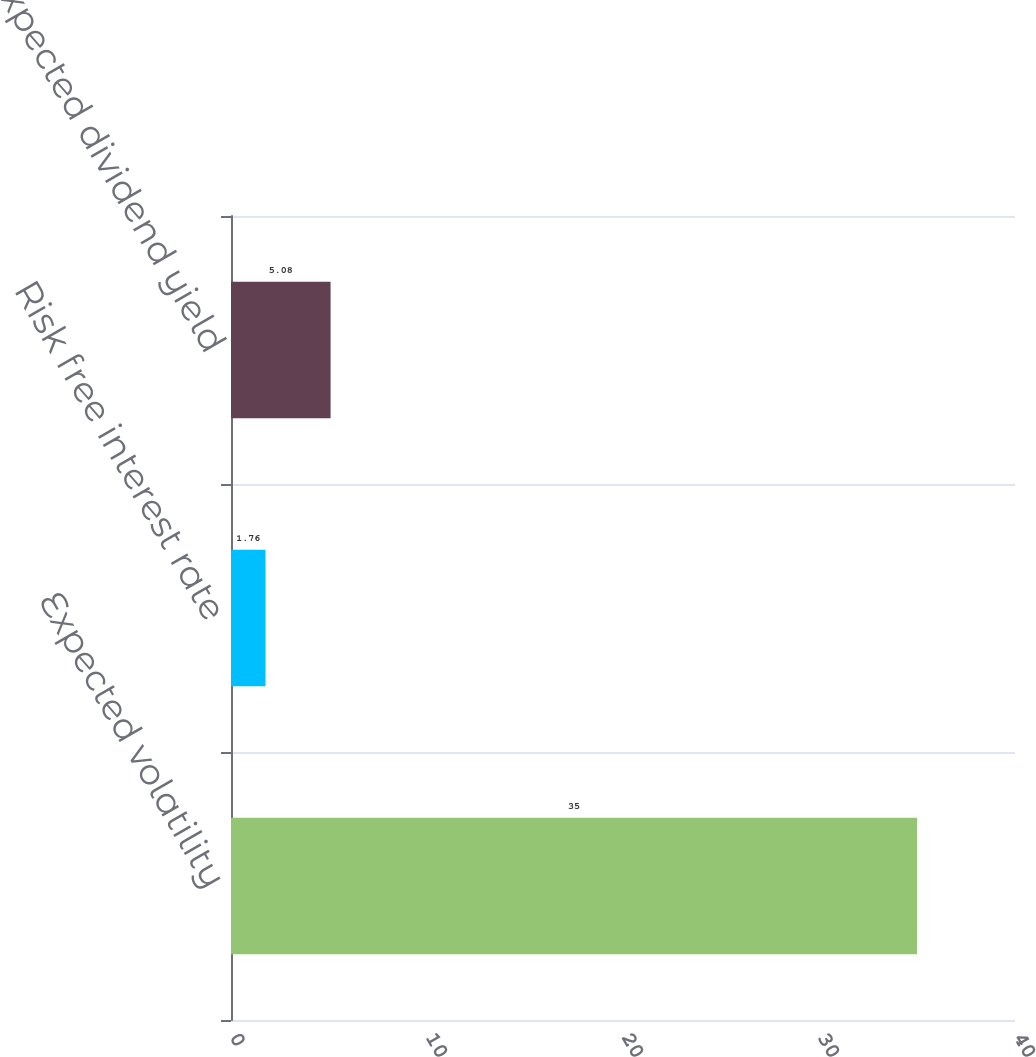<chart> <loc_0><loc_0><loc_500><loc_500><bar_chart><fcel>Expected volatility<fcel>Risk free interest rate<fcel>Expected dividend yield<nl><fcel>35<fcel>1.76<fcel>5.08<nl></chart> 